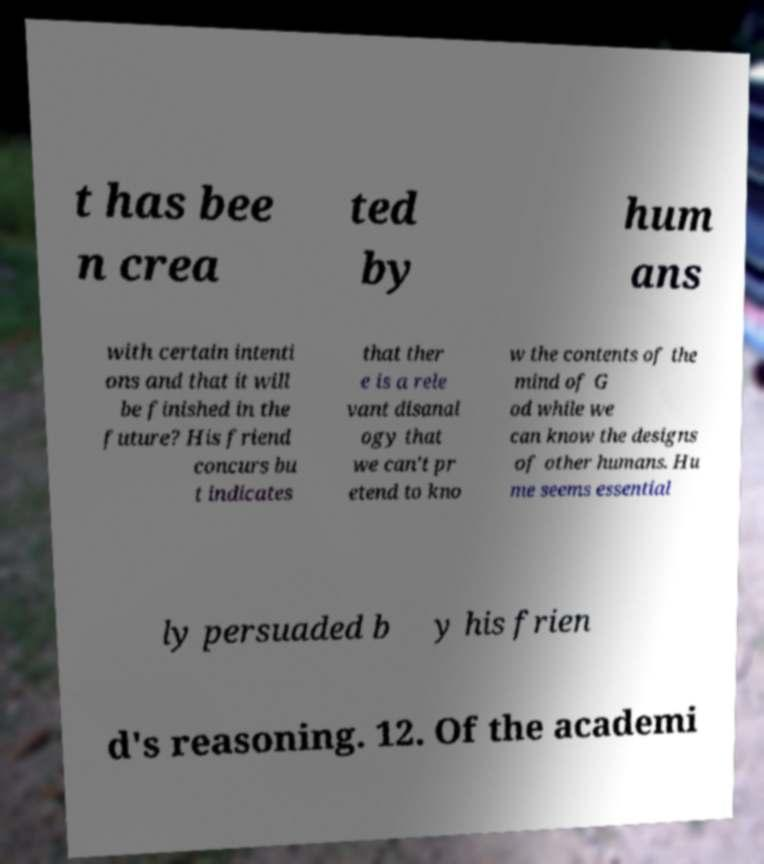Could you extract and type out the text from this image? t has bee n crea ted by hum ans with certain intenti ons and that it will be finished in the future? His friend concurs bu t indicates that ther e is a rele vant disanal ogy that we can't pr etend to kno w the contents of the mind of G od while we can know the designs of other humans. Hu me seems essential ly persuaded b y his frien d's reasoning. 12. Of the academi 